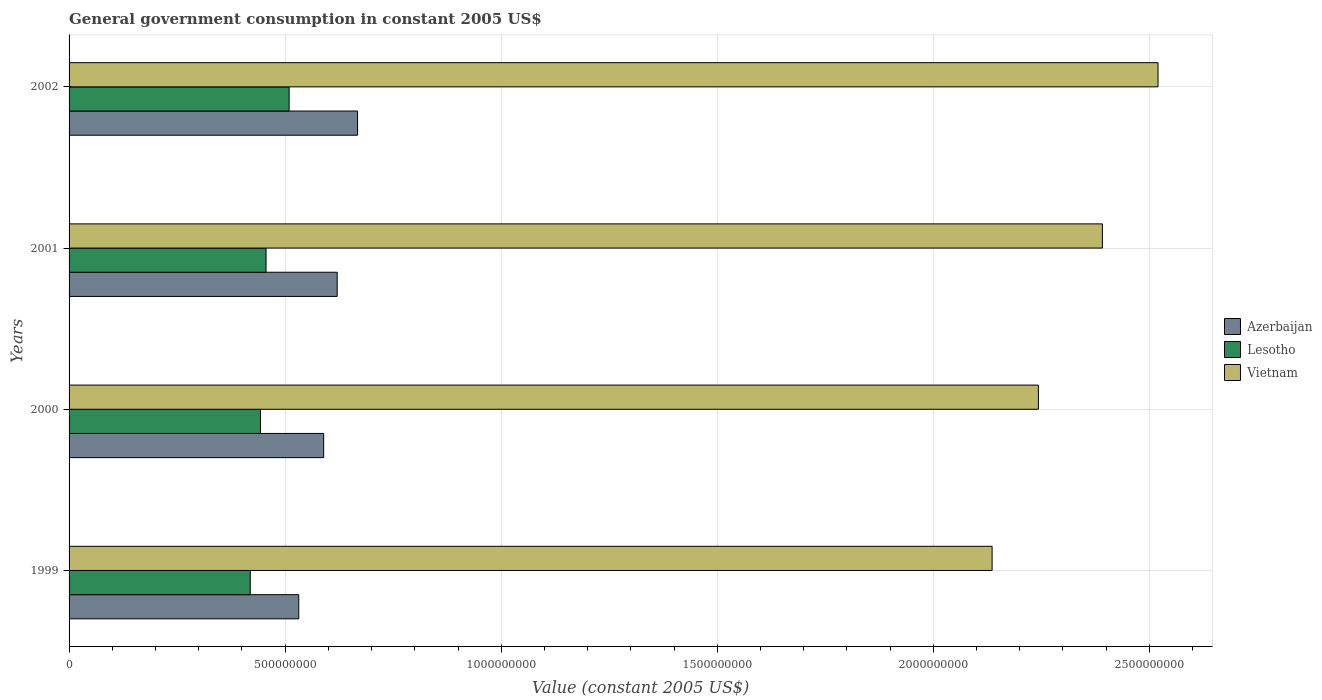How many different coloured bars are there?
Provide a succinct answer. 3. How many groups of bars are there?
Offer a very short reply. 4. Are the number of bars per tick equal to the number of legend labels?
Provide a succinct answer. Yes. How many bars are there on the 3rd tick from the bottom?
Give a very brief answer. 3. What is the government conusmption in Lesotho in 2002?
Your answer should be compact. 5.09e+08. Across all years, what is the maximum government conusmption in Vietnam?
Offer a very short reply. 2.52e+09. Across all years, what is the minimum government conusmption in Lesotho?
Provide a short and direct response. 4.19e+08. In which year was the government conusmption in Vietnam maximum?
Your answer should be very brief. 2002. What is the total government conusmption in Vietnam in the graph?
Ensure brevity in your answer.  9.29e+09. What is the difference between the government conusmption in Vietnam in 2000 and that in 2001?
Your answer should be very brief. -1.48e+08. What is the difference between the government conusmption in Vietnam in 2001 and the government conusmption in Azerbaijan in 1999?
Make the answer very short. 1.86e+09. What is the average government conusmption in Lesotho per year?
Provide a succinct answer. 4.57e+08. In the year 2002, what is the difference between the government conusmption in Lesotho and government conusmption in Azerbaijan?
Your response must be concise. -1.58e+08. In how many years, is the government conusmption in Lesotho greater than 200000000 US$?
Provide a short and direct response. 4. What is the ratio of the government conusmption in Vietnam in 1999 to that in 2001?
Your answer should be compact. 0.89. What is the difference between the highest and the second highest government conusmption in Lesotho?
Keep it short and to the point. 5.34e+07. What is the difference between the highest and the lowest government conusmption in Lesotho?
Keep it short and to the point. 9.00e+07. Is the sum of the government conusmption in Vietnam in 1999 and 2002 greater than the maximum government conusmption in Lesotho across all years?
Ensure brevity in your answer.  Yes. What does the 2nd bar from the top in 2001 represents?
Provide a succinct answer. Lesotho. What does the 2nd bar from the bottom in 2002 represents?
Provide a short and direct response. Lesotho. Is it the case that in every year, the sum of the government conusmption in Vietnam and government conusmption in Azerbaijan is greater than the government conusmption in Lesotho?
Your answer should be compact. Yes. What is the difference between two consecutive major ticks on the X-axis?
Offer a very short reply. 5.00e+08. Are the values on the major ticks of X-axis written in scientific E-notation?
Offer a terse response. No. Does the graph contain grids?
Make the answer very short. Yes. What is the title of the graph?
Offer a very short reply. General government consumption in constant 2005 US$. What is the label or title of the X-axis?
Provide a short and direct response. Value (constant 2005 US$). What is the Value (constant 2005 US$) of Azerbaijan in 1999?
Make the answer very short. 5.32e+08. What is the Value (constant 2005 US$) in Lesotho in 1999?
Offer a very short reply. 4.19e+08. What is the Value (constant 2005 US$) in Vietnam in 1999?
Offer a terse response. 2.14e+09. What is the Value (constant 2005 US$) in Azerbaijan in 2000?
Your answer should be very brief. 5.89e+08. What is the Value (constant 2005 US$) of Lesotho in 2000?
Ensure brevity in your answer.  4.43e+08. What is the Value (constant 2005 US$) of Vietnam in 2000?
Your response must be concise. 2.24e+09. What is the Value (constant 2005 US$) in Azerbaijan in 2001?
Give a very brief answer. 6.20e+08. What is the Value (constant 2005 US$) of Lesotho in 2001?
Your answer should be compact. 4.56e+08. What is the Value (constant 2005 US$) of Vietnam in 2001?
Your answer should be compact. 2.39e+09. What is the Value (constant 2005 US$) of Azerbaijan in 2002?
Give a very brief answer. 6.68e+08. What is the Value (constant 2005 US$) in Lesotho in 2002?
Ensure brevity in your answer.  5.09e+08. What is the Value (constant 2005 US$) in Vietnam in 2002?
Give a very brief answer. 2.52e+09. Across all years, what is the maximum Value (constant 2005 US$) in Azerbaijan?
Your answer should be very brief. 6.68e+08. Across all years, what is the maximum Value (constant 2005 US$) of Lesotho?
Provide a succinct answer. 5.09e+08. Across all years, what is the maximum Value (constant 2005 US$) of Vietnam?
Provide a short and direct response. 2.52e+09. Across all years, what is the minimum Value (constant 2005 US$) in Azerbaijan?
Provide a succinct answer. 5.32e+08. Across all years, what is the minimum Value (constant 2005 US$) of Lesotho?
Ensure brevity in your answer.  4.19e+08. Across all years, what is the minimum Value (constant 2005 US$) in Vietnam?
Provide a succinct answer. 2.14e+09. What is the total Value (constant 2005 US$) in Azerbaijan in the graph?
Provide a short and direct response. 2.41e+09. What is the total Value (constant 2005 US$) in Lesotho in the graph?
Provide a succinct answer. 1.83e+09. What is the total Value (constant 2005 US$) in Vietnam in the graph?
Your answer should be very brief. 9.29e+09. What is the difference between the Value (constant 2005 US$) of Azerbaijan in 1999 and that in 2000?
Offer a terse response. -5.77e+07. What is the difference between the Value (constant 2005 US$) in Lesotho in 1999 and that in 2000?
Provide a short and direct response. -2.36e+07. What is the difference between the Value (constant 2005 US$) in Vietnam in 1999 and that in 2000?
Offer a very short reply. -1.07e+08. What is the difference between the Value (constant 2005 US$) of Azerbaijan in 1999 and that in 2001?
Your answer should be very brief. -8.89e+07. What is the difference between the Value (constant 2005 US$) in Lesotho in 1999 and that in 2001?
Offer a terse response. -3.66e+07. What is the difference between the Value (constant 2005 US$) of Vietnam in 1999 and that in 2001?
Offer a terse response. -2.55e+08. What is the difference between the Value (constant 2005 US$) in Azerbaijan in 1999 and that in 2002?
Provide a short and direct response. -1.36e+08. What is the difference between the Value (constant 2005 US$) in Lesotho in 1999 and that in 2002?
Make the answer very short. -9.00e+07. What is the difference between the Value (constant 2005 US$) of Vietnam in 1999 and that in 2002?
Ensure brevity in your answer.  -3.84e+08. What is the difference between the Value (constant 2005 US$) in Azerbaijan in 2000 and that in 2001?
Provide a short and direct response. -3.13e+07. What is the difference between the Value (constant 2005 US$) in Lesotho in 2000 and that in 2001?
Offer a very short reply. -1.29e+07. What is the difference between the Value (constant 2005 US$) in Vietnam in 2000 and that in 2001?
Provide a short and direct response. -1.48e+08. What is the difference between the Value (constant 2005 US$) in Azerbaijan in 2000 and that in 2002?
Offer a very short reply. -7.85e+07. What is the difference between the Value (constant 2005 US$) of Lesotho in 2000 and that in 2002?
Ensure brevity in your answer.  -6.63e+07. What is the difference between the Value (constant 2005 US$) of Vietnam in 2000 and that in 2002?
Ensure brevity in your answer.  -2.77e+08. What is the difference between the Value (constant 2005 US$) of Azerbaijan in 2001 and that in 2002?
Keep it short and to the point. -4.72e+07. What is the difference between the Value (constant 2005 US$) in Lesotho in 2001 and that in 2002?
Offer a very short reply. -5.34e+07. What is the difference between the Value (constant 2005 US$) of Vietnam in 2001 and that in 2002?
Make the answer very short. -1.29e+08. What is the difference between the Value (constant 2005 US$) of Azerbaijan in 1999 and the Value (constant 2005 US$) of Lesotho in 2000?
Offer a very short reply. 8.86e+07. What is the difference between the Value (constant 2005 US$) in Azerbaijan in 1999 and the Value (constant 2005 US$) in Vietnam in 2000?
Ensure brevity in your answer.  -1.71e+09. What is the difference between the Value (constant 2005 US$) of Lesotho in 1999 and the Value (constant 2005 US$) of Vietnam in 2000?
Your response must be concise. -1.82e+09. What is the difference between the Value (constant 2005 US$) in Azerbaijan in 1999 and the Value (constant 2005 US$) in Lesotho in 2001?
Your response must be concise. 7.57e+07. What is the difference between the Value (constant 2005 US$) of Azerbaijan in 1999 and the Value (constant 2005 US$) of Vietnam in 2001?
Ensure brevity in your answer.  -1.86e+09. What is the difference between the Value (constant 2005 US$) of Lesotho in 1999 and the Value (constant 2005 US$) of Vietnam in 2001?
Offer a terse response. -1.97e+09. What is the difference between the Value (constant 2005 US$) in Azerbaijan in 1999 and the Value (constant 2005 US$) in Lesotho in 2002?
Keep it short and to the point. 2.23e+07. What is the difference between the Value (constant 2005 US$) of Azerbaijan in 1999 and the Value (constant 2005 US$) of Vietnam in 2002?
Keep it short and to the point. -1.99e+09. What is the difference between the Value (constant 2005 US$) of Lesotho in 1999 and the Value (constant 2005 US$) of Vietnam in 2002?
Provide a short and direct response. -2.10e+09. What is the difference between the Value (constant 2005 US$) of Azerbaijan in 2000 and the Value (constant 2005 US$) of Lesotho in 2001?
Ensure brevity in your answer.  1.33e+08. What is the difference between the Value (constant 2005 US$) of Azerbaijan in 2000 and the Value (constant 2005 US$) of Vietnam in 2001?
Provide a short and direct response. -1.80e+09. What is the difference between the Value (constant 2005 US$) of Lesotho in 2000 and the Value (constant 2005 US$) of Vietnam in 2001?
Keep it short and to the point. -1.95e+09. What is the difference between the Value (constant 2005 US$) of Azerbaijan in 2000 and the Value (constant 2005 US$) of Lesotho in 2002?
Your response must be concise. 7.99e+07. What is the difference between the Value (constant 2005 US$) of Azerbaijan in 2000 and the Value (constant 2005 US$) of Vietnam in 2002?
Keep it short and to the point. -1.93e+09. What is the difference between the Value (constant 2005 US$) in Lesotho in 2000 and the Value (constant 2005 US$) in Vietnam in 2002?
Your response must be concise. -2.08e+09. What is the difference between the Value (constant 2005 US$) in Azerbaijan in 2001 and the Value (constant 2005 US$) in Lesotho in 2002?
Your response must be concise. 1.11e+08. What is the difference between the Value (constant 2005 US$) in Azerbaijan in 2001 and the Value (constant 2005 US$) in Vietnam in 2002?
Offer a very short reply. -1.90e+09. What is the difference between the Value (constant 2005 US$) of Lesotho in 2001 and the Value (constant 2005 US$) of Vietnam in 2002?
Your answer should be compact. -2.06e+09. What is the average Value (constant 2005 US$) in Azerbaijan per year?
Give a very brief answer. 6.02e+08. What is the average Value (constant 2005 US$) in Lesotho per year?
Keep it short and to the point. 4.57e+08. What is the average Value (constant 2005 US$) in Vietnam per year?
Keep it short and to the point. 2.32e+09. In the year 1999, what is the difference between the Value (constant 2005 US$) in Azerbaijan and Value (constant 2005 US$) in Lesotho?
Offer a very short reply. 1.12e+08. In the year 1999, what is the difference between the Value (constant 2005 US$) in Azerbaijan and Value (constant 2005 US$) in Vietnam?
Offer a terse response. -1.60e+09. In the year 1999, what is the difference between the Value (constant 2005 US$) of Lesotho and Value (constant 2005 US$) of Vietnam?
Keep it short and to the point. -1.72e+09. In the year 2000, what is the difference between the Value (constant 2005 US$) of Azerbaijan and Value (constant 2005 US$) of Lesotho?
Make the answer very short. 1.46e+08. In the year 2000, what is the difference between the Value (constant 2005 US$) of Azerbaijan and Value (constant 2005 US$) of Vietnam?
Offer a very short reply. -1.65e+09. In the year 2000, what is the difference between the Value (constant 2005 US$) in Lesotho and Value (constant 2005 US$) in Vietnam?
Your answer should be very brief. -1.80e+09. In the year 2001, what is the difference between the Value (constant 2005 US$) of Azerbaijan and Value (constant 2005 US$) of Lesotho?
Your answer should be compact. 1.65e+08. In the year 2001, what is the difference between the Value (constant 2005 US$) in Azerbaijan and Value (constant 2005 US$) in Vietnam?
Provide a succinct answer. -1.77e+09. In the year 2001, what is the difference between the Value (constant 2005 US$) in Lesotho and Value (constant 2005 US$) in Vietnam?
Offer a very short reply. -1.94e+09. In the year 2002, what is the difference between the Value (constant 2005 US$) in Azerbaijan and Value (constant 2005 US$) in Lesotho?
Keep it short and to the point. 1.58e+08. In the year 2002, what is the difference between the Value (constant 2005 US$) in Azerbaijan and Value (constant 2005 US$) in Vietnam?
Provide a short and direct response. -1.85e+09. In the year 2002, what is the difference between the Value (constant 2005 US$) in Lesotho and Value (constant 2005 US$) in Vietnam?
Your answer should be compact. -2.01e+09. What is the ratio of the Value (constant 2005 US$) of Azerbaijan in 1999 to that in 2000?
Offer a very short reply. 0.9. What is the ratio of the Value (constant 2005 US$) of Lesotho in 1999 to that in 2000?
Offer a very short reply. 0.95. What is the ratio of the Value (constant 2005 US$) of Vietnam in 1999 to that in 2000?
Offer a very short reply. 0.95. What is the ratio of the Value (constant 2005 US$) of Azerbaijan in 1999 to that in 2001?
Ensure brevity in your answer.  0.86. What is the ratio of the Value (constant 2005 US$) in Lesotho in 1999 to that in 2001?
Make the answer very short. 0.92. What is the ratio of the Value (constant 2005 US$) of Vietnam in 1999 to that in 2001?
Give a very brief answer. 0.89. What is the ratio of the Value (constant 2005 US$) in Azerbaijan in 1999 to that in 2002?
Ensure brevity in your answer.  0.8. What is the ratio of the Value (constant 2005 US$) in Lesotho in 1999 to that in 2002?
Keep it short and to the point. 0.82. What is the ratio of the Value (constant 2005 US$) of Vietnam in 1999 to that in 2002?
Keep it short and to the point. 0.85. What is the ratio of the Value (constant 2005 US$) of Azerbaijan in 2000 to that in 2001?
Provide a short and direct response. 0.95. What is the ratio of the Value (constant 2005 US$) in Lesotho in 2000 to that in 2001?
Your answer should be compact. 0.97. What is the ratio of the Value (constant 2005 US$) in Vietnam in 2000 to that in 2001?
Keep it short and to the point. 0.94. What is the ratio of the Value (constant 2005 US$) of Azerbaijan in 2000 to that in 2002?
Your answer should be compact. 0.88. What is the ratio of the Value (constant 2005 US$) in Lesotho in 2000 to that in 2002?
Provide a succinct answer. 0.87. What is the ratio of the Value (constant 2005 US$) in Vietnam in 2000 to that in 2002?
Your answer should be very brief. 0.89. What is the ratio of the Value (constant 2005 US$) of Azerbaijan in 2001 to that in 2002?
Ensure brevity in your answer.  0.93. What is the ratio of the Value (constant 2005 US$) in Lesotho in 2001 to that in 2002?
Provide a short and direct response. 0.9. What is the ratio of the Value (constant 2005 US$) in Vietnam in 2001 to that in 2002?
Offer a terse response. 0.95. What is the difference between the highest and the second highest Value (constant 2005 US$) of Azerbaijan?
Your answer should be compact. 4.72e+07. What is the difference between the highest and the second highest Value (constant 2005 US$) in Lesotho?
Give a very brief answer. 5.34e+07. What is the difference between the highest and the second highest Value (constant 2005 US$) in Vietnam?
Offer a very short reply. 1.29e+08. What is the difference between the highest and the lowest Value (constant 2005 US$) of Azerbaijan?
Ensure brevity in your answer.  1.36e+08. What is the difference between the highest and the lowest Value (constant 2005 US$) of Lesotho?
Keep it short and to the point. 9.00e+07. What is the difference between the highest and the lowest Value (constant 2005 US$) in Vietnam?
Keep it short and to the point. 3.84e+08. 